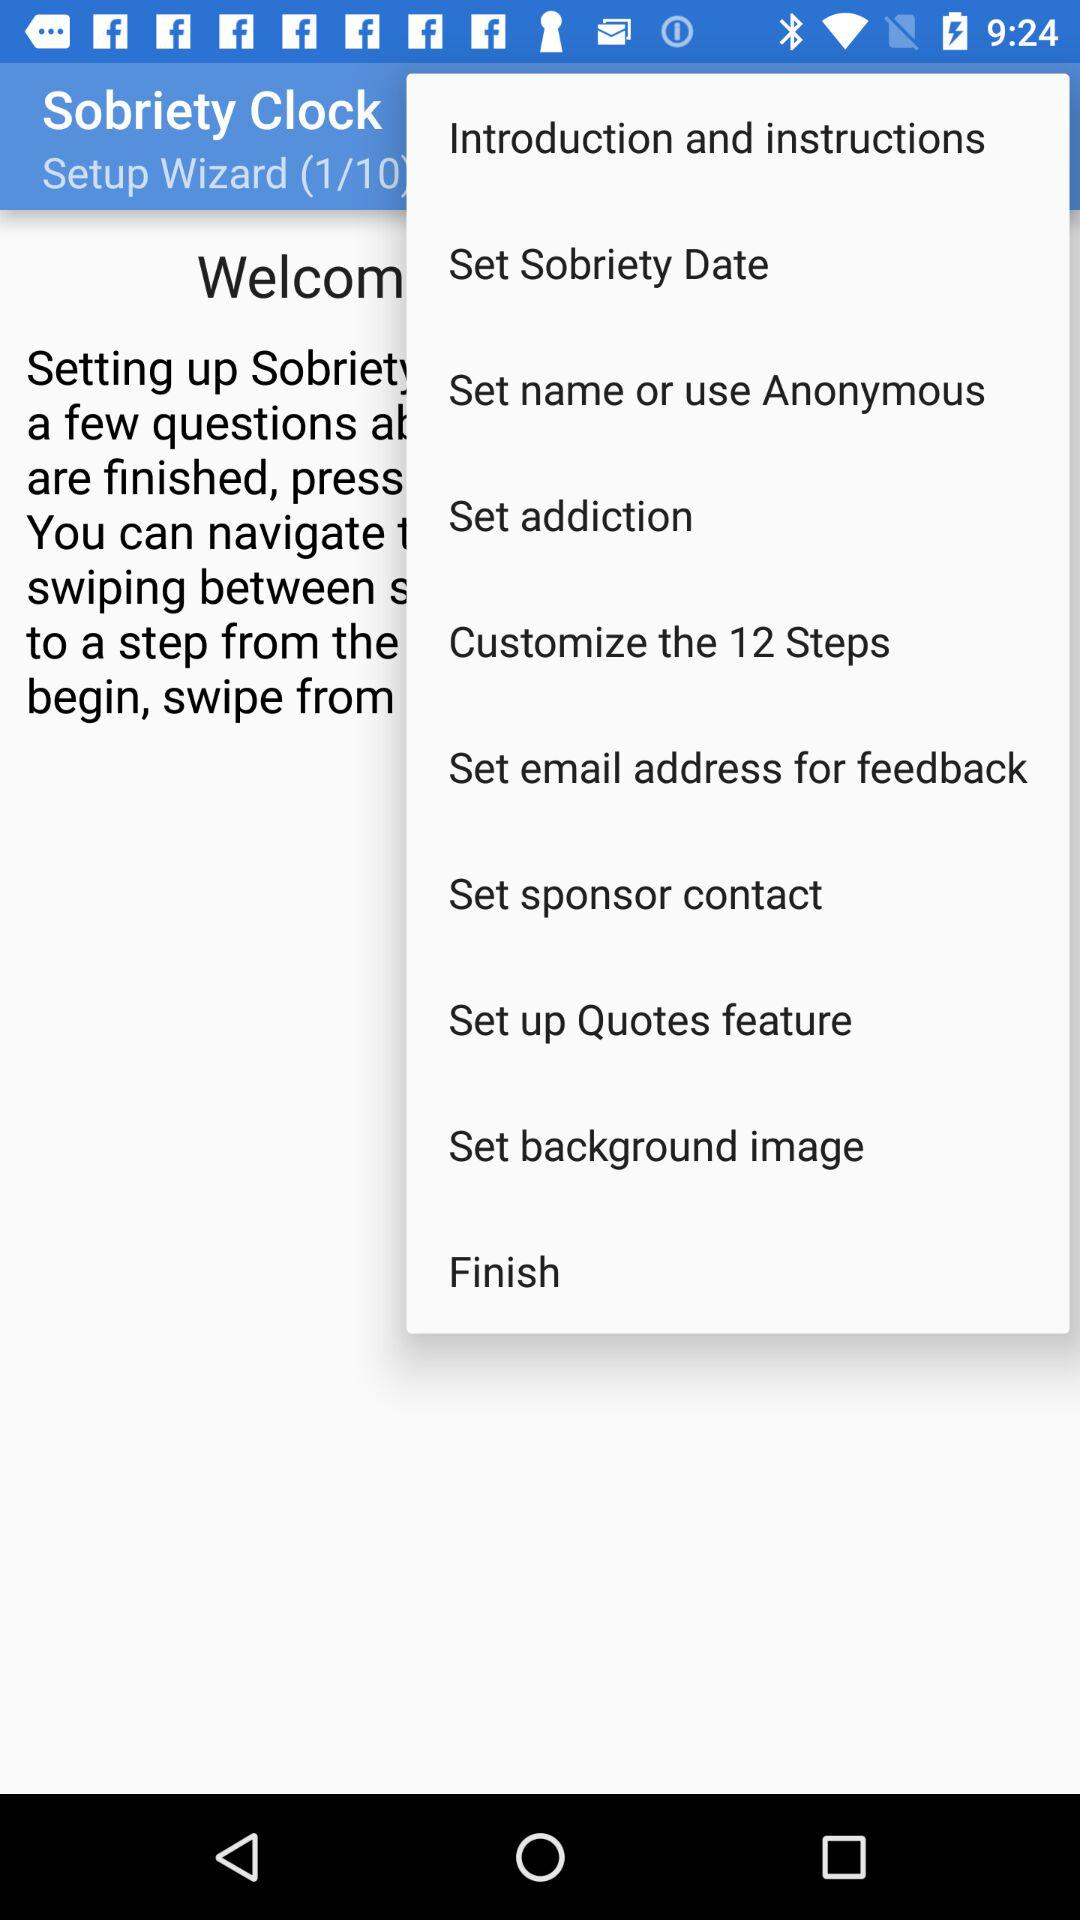How many steps are there in the setup wizard?
Answer the question using a single word or phrase. 10 